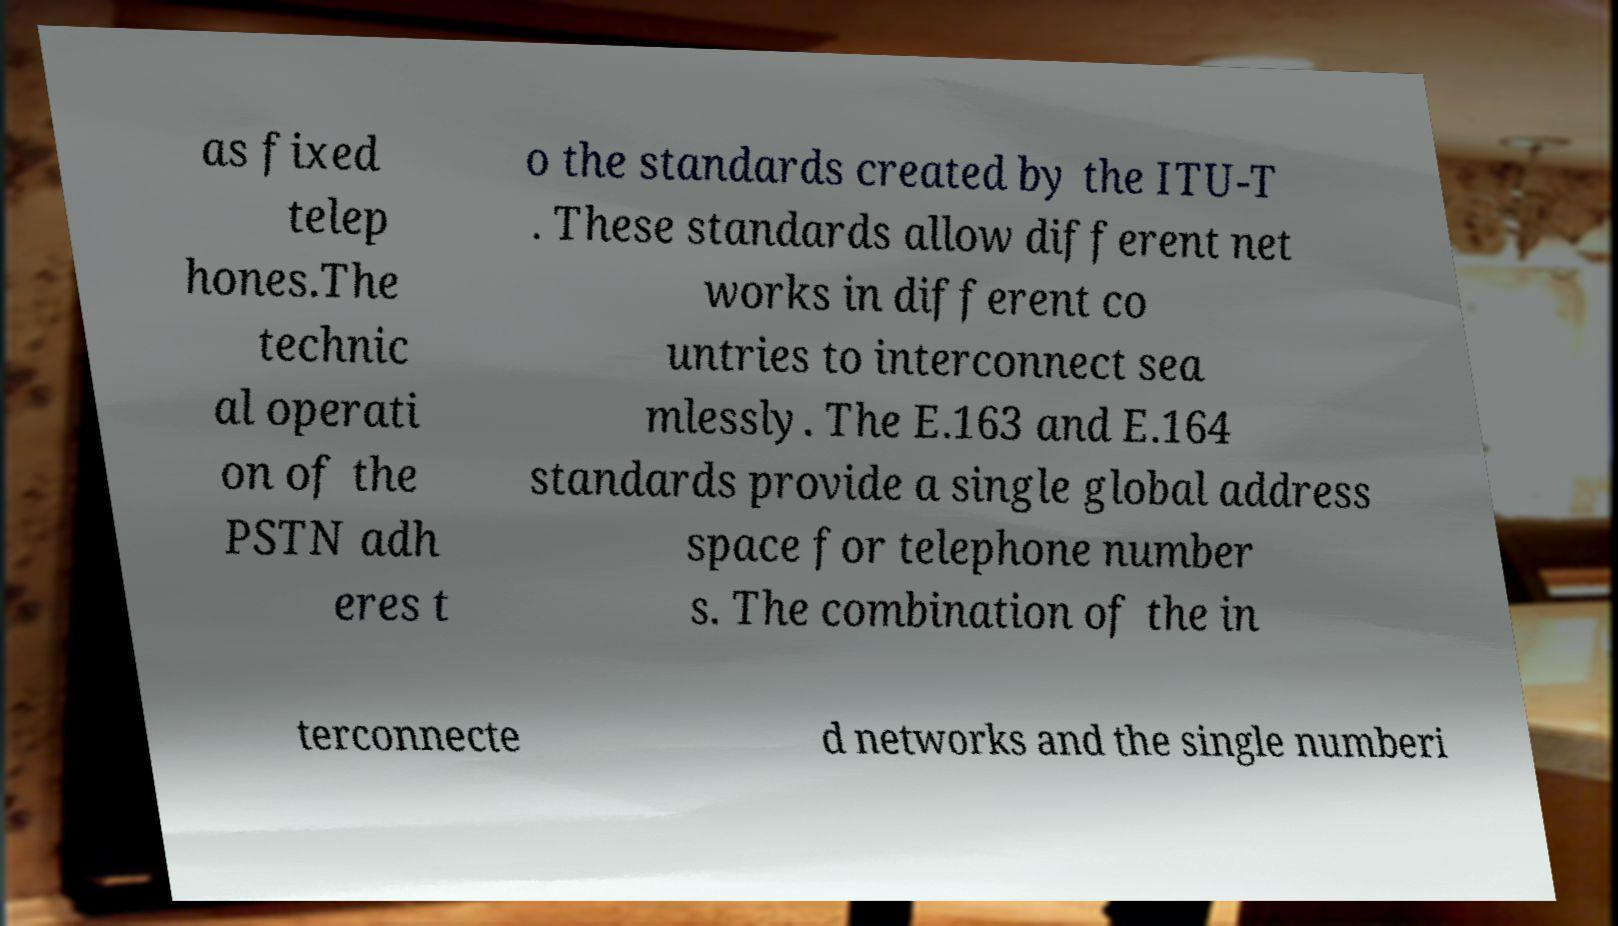There's text embedded in this image that I need extracted. Can you transcribe it verbatim? as fixed telep hones.The technic al operati on of the PSTN adh eres t o the standards created by the ITU-T . These standards allow different net works in different co untries to interconnect sea mlessly. The E.163 and E.164 standards provide a single global address space for telephone number s. The combination of the in terconnecte d networks and the single numberi 